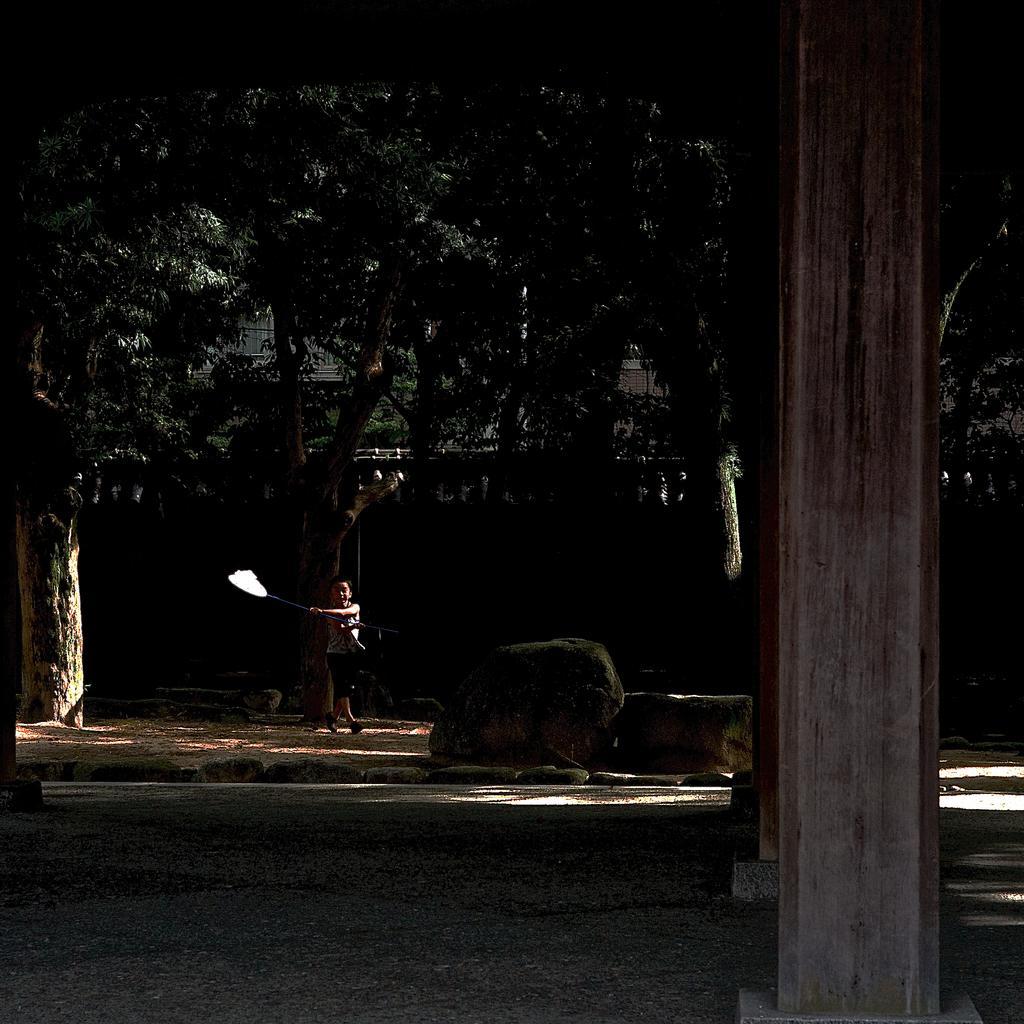Could you give a brief overview of what you see in this image? In this image we can see children holding an object. And we can see the stones and pillars. In the background, we can see the trees. And the given image is dark. 